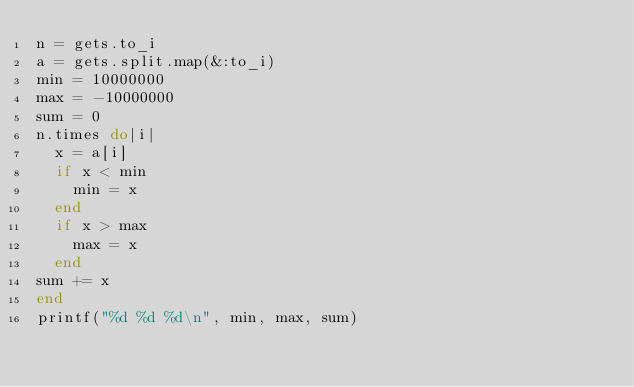Convert code to text. <code><loc_0><loc_0><loc_500><loc_500><_Ruby_>n = gets.to_i
a = gets.split.map(&:to_i)
min = 10000000
max = -10000000
sum = 0
n.times do|i|
  x = a[i]
  if x < min
    min = x
  end
  if x > max
    max = x
  end
sum += x
end
printf("%d %d %d\n", min, max, sum)

</code> 